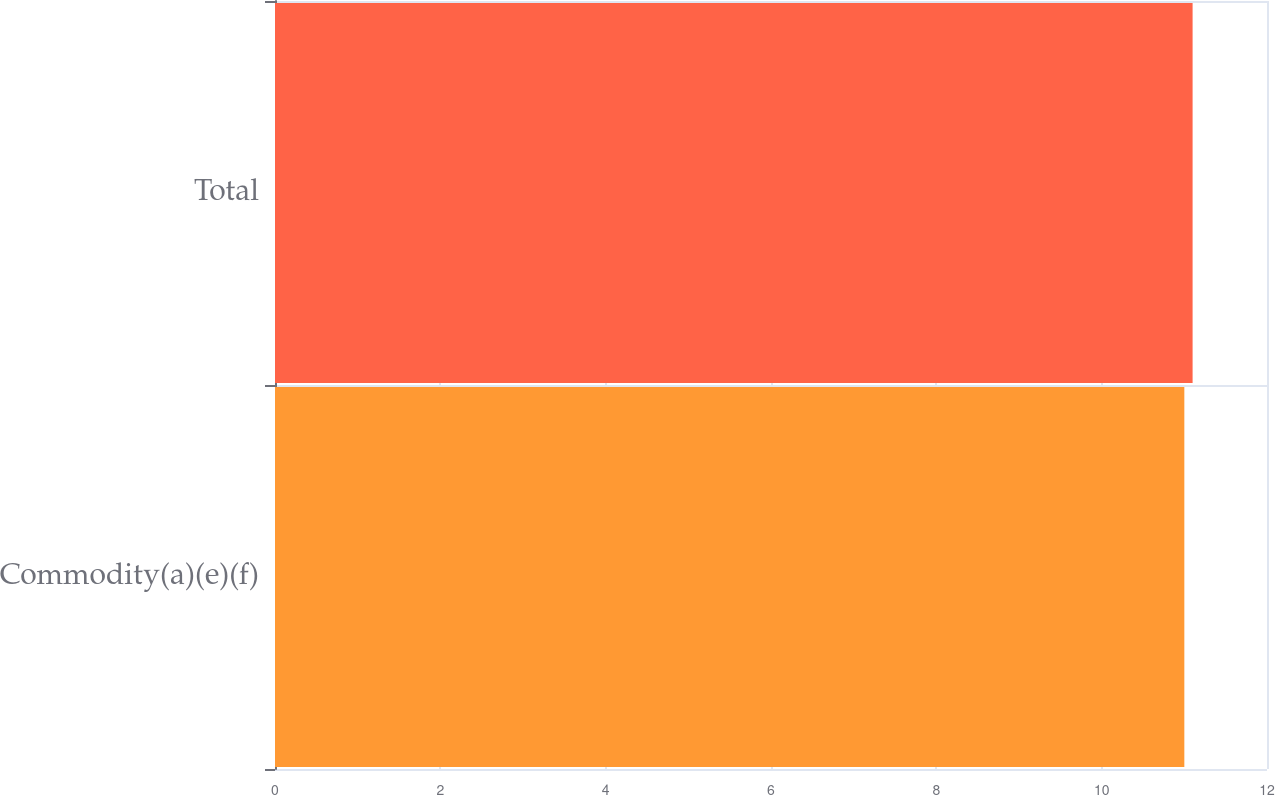Convert chart. <chart><loc_0><loc_0><loc_500><loc_500><bar_chart><fcel>Commodity(a)(e)(f)<fcel>Total<nl><fcel>11<fcel>11.1<nl></chart> 